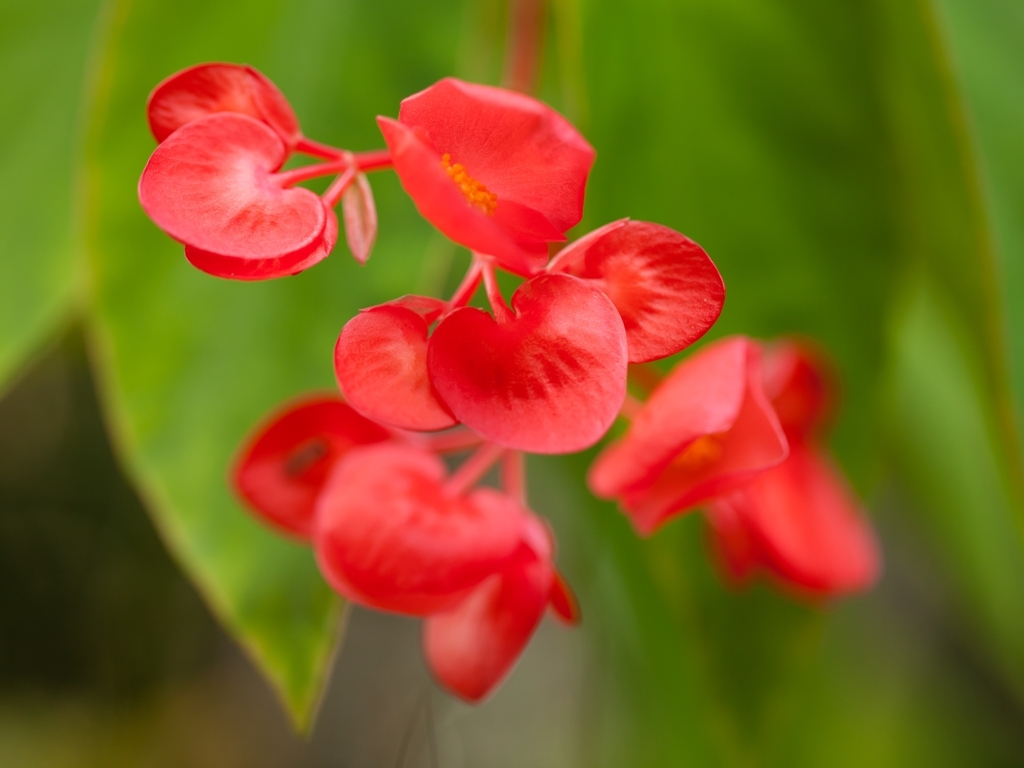Could you explain how the depth of field affects the perception of this photo? Certainly. The depth of field in this photo is shallow, which means that only a small portion of the image, particularly the flower, is in sharp focus. This technique draws the viewer's attention directly to the flower, making it the clear subject of the photo. The background is nicely blurred, known as bokeh, which further emphasizes the flower and gives the image an artistic quality. 